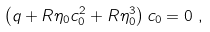<formula> <loc_0><loc_0><loc_500><loc_500>\left ( q + R \eta _ { 0 } c _ { 0 } ^ { 2 } + R \eta _ { 0 } ^ { 3 } \right ) c _ { 0 } & = 0 \ ,</formula> 